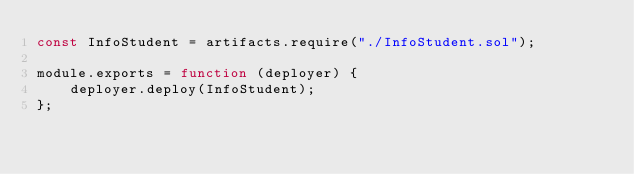<code> <loc_0><loc_0><loc_500><loc_500><_JavaScript_>const InfoStudent = artifacts.require("./InfoStudent.sol");

module.exports = function (deployer) {
    deployer.deploy(InfoStudent);
};
</code> 